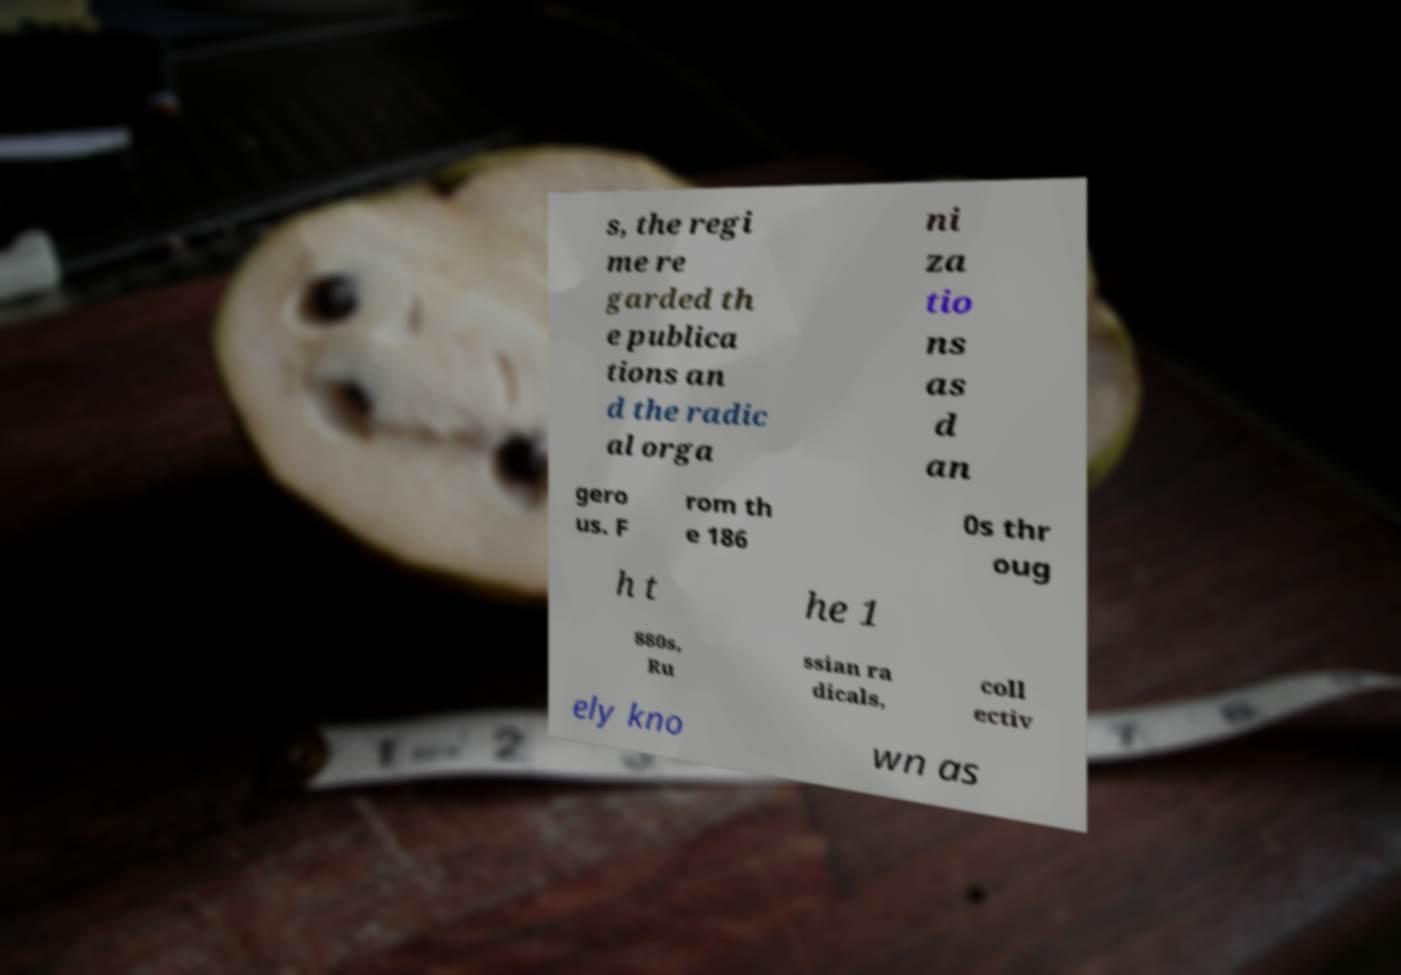Could you extract and type out the text from this image? s, the regi me re garded th e publica tions an d the radic al orga ni za tio ns as d an gero us. F rom th e 186 0s thr oug h t he 1 880s, Ru ssian ra dicals, coll ectiv ely kno wn as 